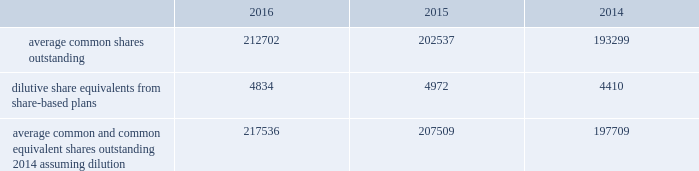Notes to consolidated financial statements 2014 ( continued ) becton , dickinson and company ( b ) these reclassifications were recorded to interest expense and cost of products sold .
Additional details regarding the company's cash flow hedges are provided in note 13 .
On august 25 , 2016 , in anticipation of proceeds to be received from the divestiture of the respiratory solutions business in the first quarter of fiscal year 2017 , the company entered into an accelerated share repurchase ( "asr" ) agreement .
Subsequent to the end of the company's fiscal year 2016 and as per the terms of the asr agreement , the company received approximately 1.3 million shares of its common stock , which was recorded as a $ 220 million increase to common stock in treasury .
Note 4 2014 earnings per share the weighted average common shares used in the computations of basic and diluted earnings per share ( shares in thousands ) for the years ended september 30 were as follows: .
Average common and common equivalent shares outstanding 2014 assuming dilution 217536 207509 197709 upon closing the acquisition of carefusion corporation ( 201ccarefusion 201d ) on march 17 , 2015 , the company issued approximately 15.9 million of its common shares as part of the purchase consideration .
Additional disclosures regarding this acquisition are provided in note 9 .
Options to purchase shares of common stock are excluded from the calculation of diluted earnings per share when their inclusion would have an anti-dilutive effect on the calculation .
For the years ended september 30 , 2016 , 2015 and 2014 there were no options to purchase shares of common stock which were excluded from the diluted earnings per share calculation. .
As of september 30 ,2014 what was the percent of the total average common and common equivalent shares outstanding 2014 assuming dilution that was dilute share equivalents from share-based plans? 
Computations: (4410 / 197709)
Answer: 0.02231. Notes to consolidated financial statements 2014 ( continued ) becton , dickinson and company ( b ) these reclassifications were recorded to interest expense and cost of products sold .
Additional details regarding the company's cash flow hedges are provided in note 13 .
On august 25 , 2016 , in anticipation of proceeds to be received from the divestiture of the respiratory solutions business in the first quarter of fiscal year 2017 , the company entered into an accelerated share repurchase ( "asr" ) agreement .
Subsequent to the end of the company's fiscal year 2016 and as per the terms of the asr agreement , the company received approximately 1.3 million shares of its common stock , which was recorded as a $ 220 million increase to common stock in treasury .
Note 4 2014 earnings per share the weighted average common shares used in the computations of basic and diluted earnings per share ( shares in thousands ) for the years ended september 30 were as follows: .
Average common and common equivalent shares outstanding 2014 assuming dilution 217536 207509 197709 upon closing the acquisition of carefusion corporation ( 201ccarefusion 201d ) on march 17 , 2015 , the company issued approximately 15.9 million of its common shares as part of the purchase consideration .
Additional disclosures regarding this acquisition are provided in note 9 .
Options to purchase shares of common stock are excluded from the calculation of diluted earnings per share when their inclusion would have an anti-dilutive effect on the calculation .
For the years ended september 30 , 2016 , 2015 and 2014 there were no options to purchase shares of common stock which were excluded from the diluted earnings per share calculation. .
What is the total number of outstanding shares from 2014-2016? 
Computations: ((212702 + 202537) + 193299)
Answer: 608538.0. Notes to consolidated financial statements 2014 ( continued ) becton , dickinson and company ( b ) these reclassifications were recorded to interest expense and cost of products sold .
Additional details regarding the company's cash flow hedges are provided in note 13 .
On august 25 , 2016 , in anticipation of proceeds to be received from the divestiture of the respiratory solutions business in the first quarter of fiscal year 2017 , the company entered into an accelerated share repurchase ( "asr" ) agreement .
Subsequent to the end of the company's fiscal year 2016 and as per the terms of the asr agreement , the company received approximately 1.3 million shares of its common stock , which was recorded as a $ 220 million increase to common stock in treasury .
Note 4 2014 earnings per share the weighted average common shares used in the computations of basic and diluted earnings per share ( shares in thousands ) for the years ended september 30 were as follows: .
Average common and common equivalent shares outstanding 2014 assuming dilution 217536 207509 197709 upon closing the acquisition of carefusion corporation ( 201ccarefusion 201d ) on march 17 , 2015 , the company issued approximately 15.9 million of its common shares as part of the purchase consideration .
Additional disclosures regarding this acquisition are provided in note 9 .
Options to purchase shares of common stock are excluded from the calculation of diluted earnings per share when their inclusion would have an anti-dilutive effect on the calculation .
For the years ended september 30 , 2016 , 2015 and 2014 there were no options to purchase shares of common stock which were excluded from the diluted earnings per share calculation. .
What is the mathematical range of dilutive share equivalents from share-based plans for 2014-2016? 
Computations: (4972 - 4410)
Answer: 562.0. 